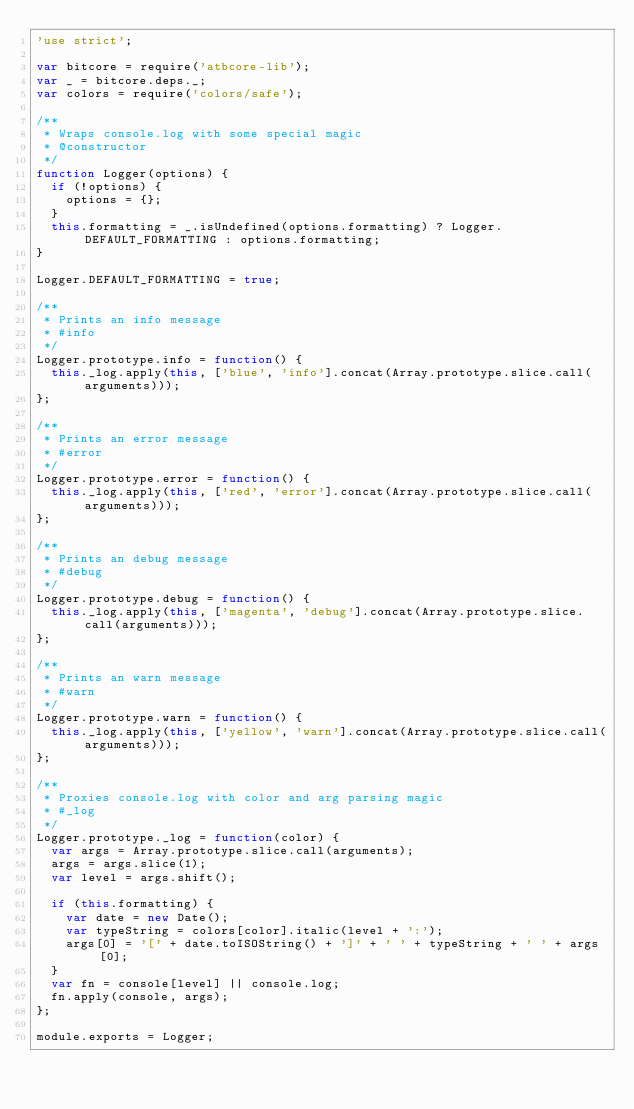Convert code to text. <code><loc_0><loc_0><loc_500><loc_500><_JavaScript_>'use strict';

var bitcore = require('atbcore-lib');
var _ = bitcore.deps._;
var colors = require('colors/safe');

/**
 * Wraps console.log with some special magic
 * @constructor
 */
function Logger(options) {
  if (!options) {
    options = {};
  }
  this.formatting = _.isUndefined(options.formatting) ? Logger.DEFAULT_FORMATTING : options.formatting;
}

Logger.DEFAULT_FORMATTING = true;

/**
 * Prints an info message
 * #info
 */
Logger.prototype.info = function() {
  this._log.apply(this, ['blue', 'info'].concat(Array.prototype.slice.call(arguments)));
};

/**
 * Prints an error message
 * #error
 */
Logger.prototype.error = function() {
  this._log.apply(this, ['red', 'error'].concat(Array.prototype.slice.call(arguments)));
};

/**
 * Prints an debug message
 * #debug
 */
Logger.prototype.debug = function() {
  this._log.apply(this, ['magenta', 'debug'].concat(Array.prototype.slice.call(arguments)));
};

/**
 * Prints an warn message
 * #warn
 */
Logger.prototype.warn = function() {
  this._log.apply(this, ['yellow', 'warn'].concat(Array.prototype.slice.call(arguments)));
};

/**
 * Proxies console.log with color and arg parsing magic
 * #_log
 */
Logger.prototype._log = function(color) {
  var args = Array.prototype.slice.call(arguments);
  args = args.slice(1);
  var level = args.shift();

  if (this.formatting) {
    var date = new Date();
    var typeString = colors[color].italic(level + ':');
    args[0] = '[' + date.toISOString() + ']' + ' ' + typeString + ' ' + args[0];
  }
  var fn = console[level] || console.log;
  fn.apply(console, args);
};

module.exports = Logger;
</code> 